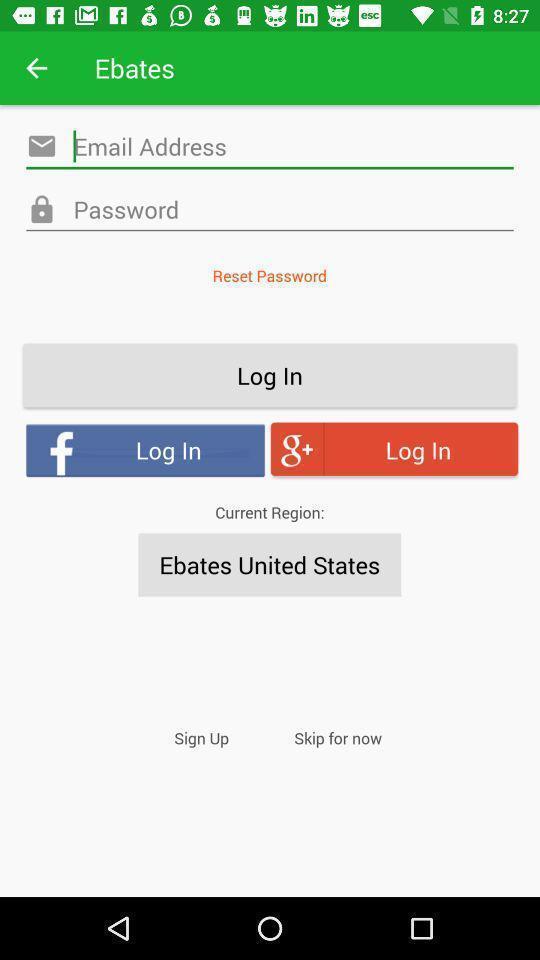Describe the content in this image. Welcome to the login page. 